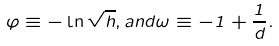<formula> <loc_0><loc_0><loc_500><loc_500>\varphi \equiv - \ln \sqrt { h } , a n d \omega \equiv - 1 + \frac { 1 } { d } .</formula> 